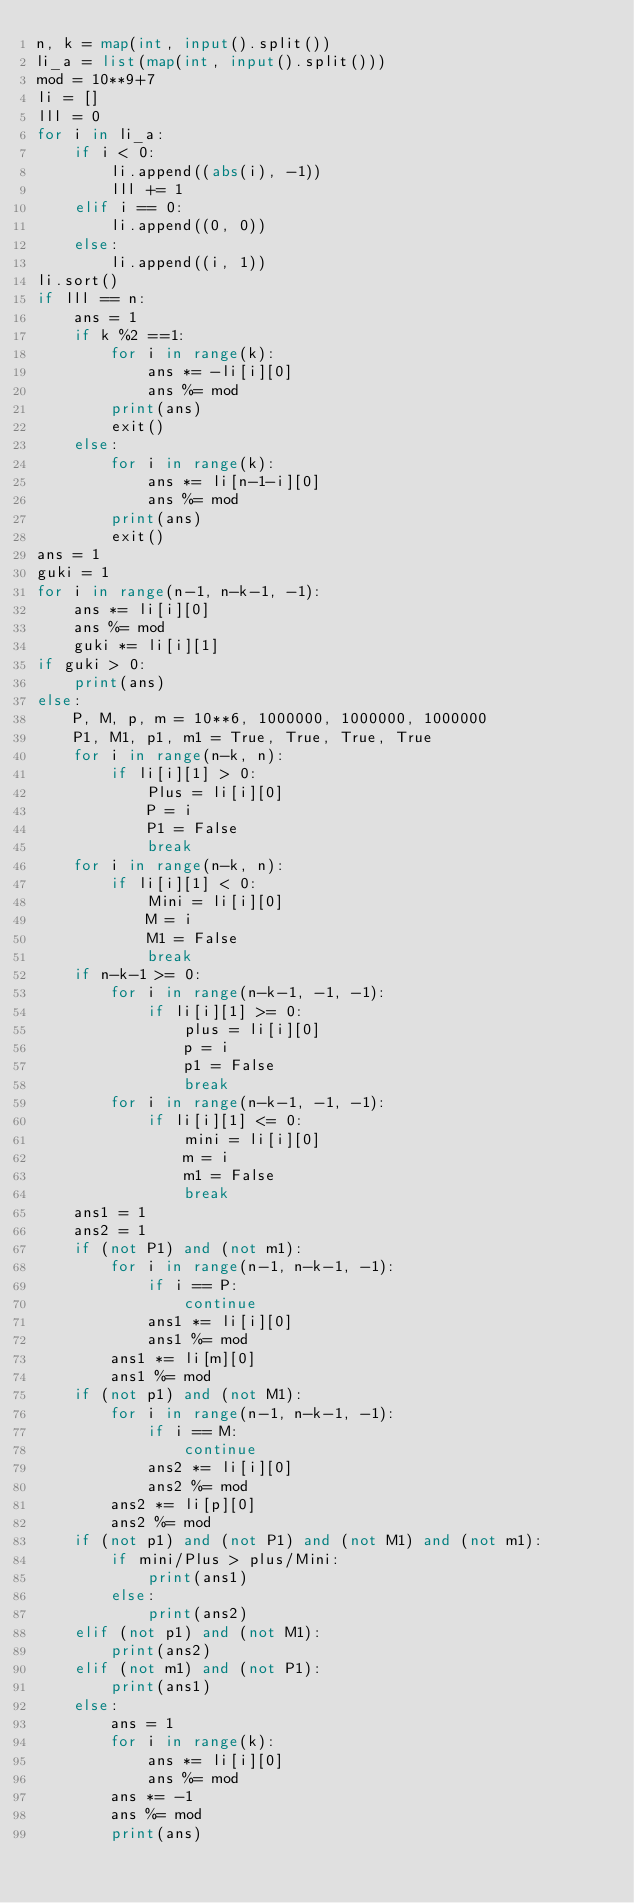<code> <loc_0><loc_0><loc_500><loc_500><_Python_>n, k = map(int, input().split())
li_a = list(map(int, input().split()))
mod = 10**9+7
li = []
lll = 0
for i in li_a:
    if i < 0:
        li.append((abs(i), -1))
        lll += 1
    elif i == 0:
        li.append((0, 0))
    else:
        li.append((i, 1))
li.sort()
if lll == n:
    ans = 1
    if k %2 ==1:
        for i in range(k):
            ans *= -li[i][0]
            ans %= mod
        print(ans)
        exit()
    else:
        for i in range(k):
            ans *= li[n-1-i][0]
            ans %= mod
        print(ans)
        exit()
ans = 1
guki = 1
for i in range(n-1, n-k-1, -1):
    ans *= li[i][0]
    ans %= mod
    guki *= li[i][1]
if guki > 0:
    print(ans)
else:
    P, M, p, m = 10**6, 1000000, 1000000, 1000000
    P1, M1, p1, m1 = True, True, True, True
    for i in range(n-k, n):
        if li[i][1] > 0:
            Plus = li[i][0]
            P = i
            P1 = False
            break
    for i in range(n-k, n):
        if li[i][1] < 0:
            Mini = li[i][0]
            M = i
            M1 = False
            break
    if n-k-1 >= 0:
        for i in range(n-k-1, -1, -1):
            if li[i][1] >= 0:
                plus = li[i][0]
                p = i
                p1 = False
                break
        for i in range(n-k-1, -1, -1):
            if li[i][1] <= 0:
                mini = li[i][0]
                m = i
                m1 = False
                break
    ans1 = 1
    ans2 = 1
    if (not P1) and (not m1):
        for i in range(n-1, n-k-1, -1):
            if i == P:
                continue
            ans1 *= li[i][0]
            ans1 %= mod
        ans1 *= li[m][0]
        ans1 %= mod
    if (not p1) and (not M1):
        for i in range(n-1, n-k-1, -1):
            if i == M:
                continue
            ans2 *= li[i][0]
            ans2 %= mod
        ans2 *= li[p][0]
        ans2 %= mod
    if (not p1) and (not P1) and (not M1) and (not m1):
        if mini/Plus > plus/Mini:
            print(ans1)
        else:
            print(ans2)
    elif (not p1) and (not M1):
        print(ans2)
    elif (not m1) and (not P1):
        print(ans1)
    else:
        ans = 1
        for i in range(k):
            ans *= li[i][0]
            ans %= mod
        ans *= -1
        ans %= mod
        print(ans)
</code> 